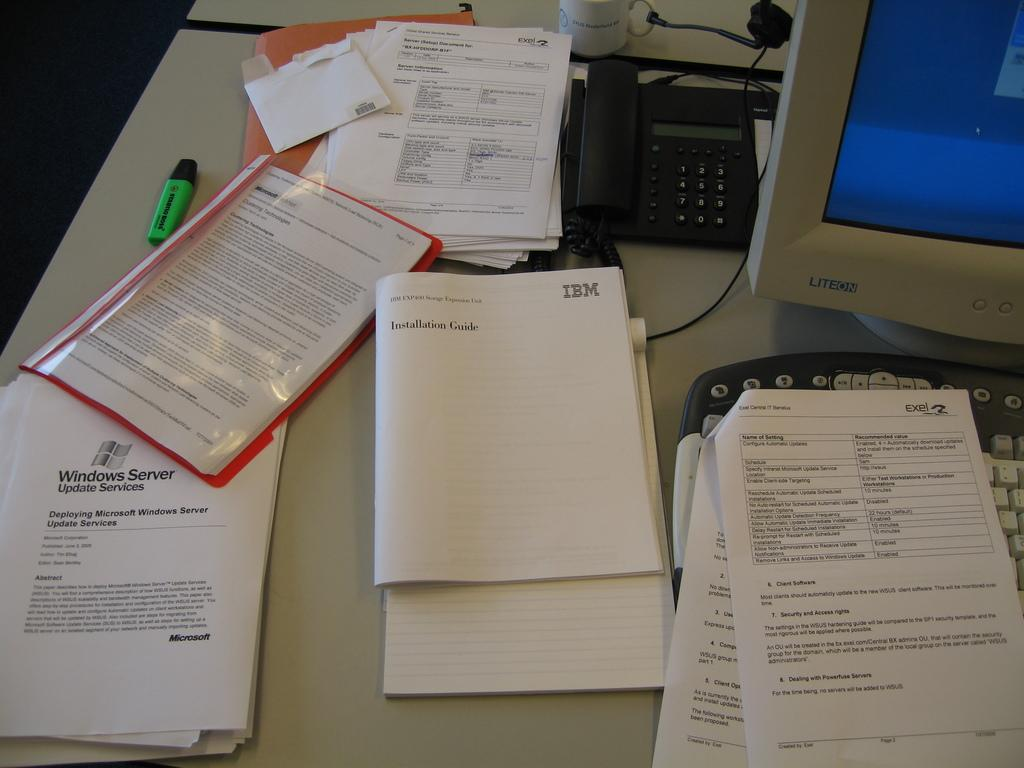<image>
Summarize the visual content of the image. An IBM instruction guide sits on a desk next to a computer. 